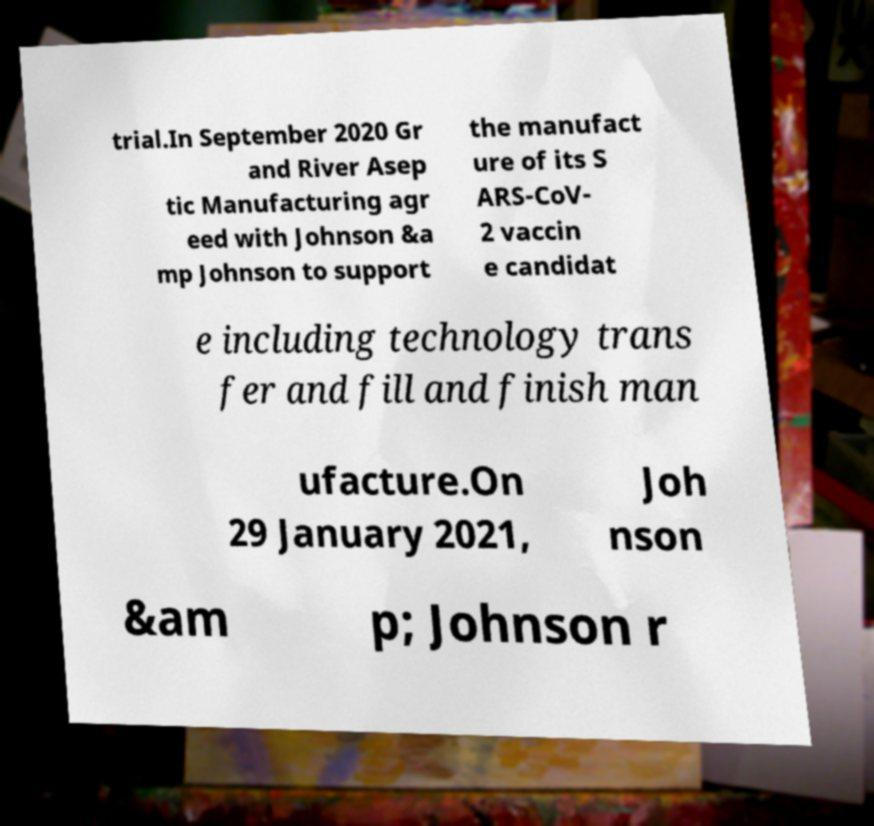There's text embedded in this image that I need extracted. Can you transcribe it verbatim? trial.In September 2020 Gr and River Asep tic Manufacturing agr eed with Johnson &a mp Johnson to support the manufact ure of its S ARS-CoV- 2 vaccin e candidat e including technology trans fer and fill and finish man ufacture.On 29 January 2021, Joh nson &am p; Johnson r 